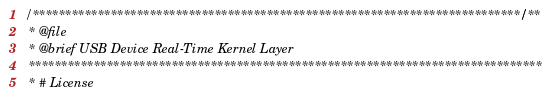Convert code to text. <code><loc_0><loc_0><loc_500><loc_500><_C_>/***************************************************************************//**
 * @file
 * @brief USB Device Real-Time Kernel Layer
 *******************************************************************************
 * # License</code> 